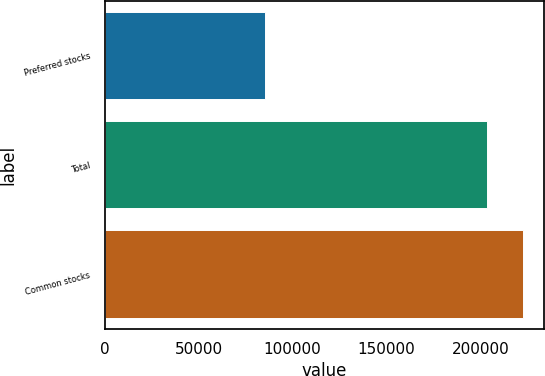Convert chart to OTSL. <chart><loc_0><loc_0><loc_500><loc_500><bar_chart><fcel>Preferred stocks<fcel>Total<fcel>Common stocks<nl><fcel>85091<fcel>203627<fcel>222671<nl></chart> 